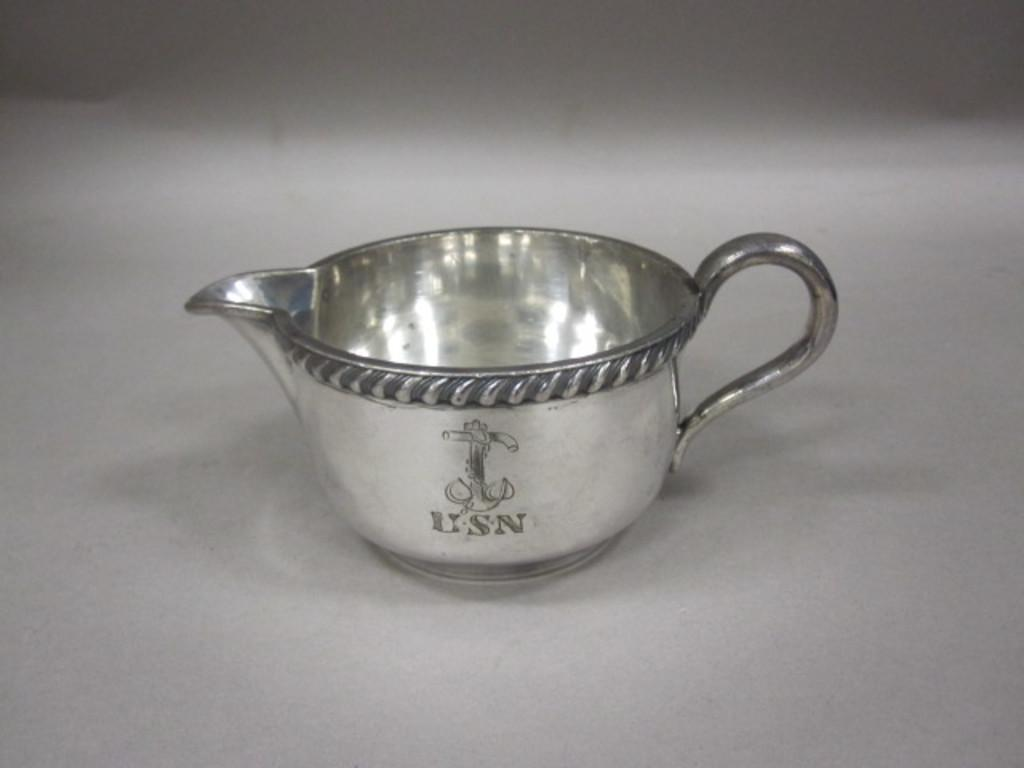What type of cup is visible in the image? There is a metal cup in the image. Where is the metal cup located? The metal cup is on a surface. What type of locket is hanging around the monkey's neck in the image? There is no monkey or locket present in the image; it only features a metal cup on a surface. 